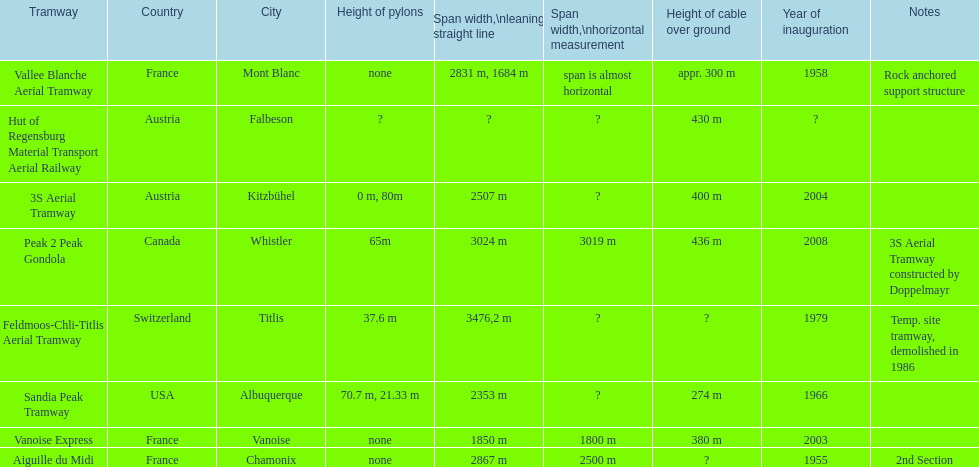At least how many aerial tramways were inaugurated after 1970? 4. 